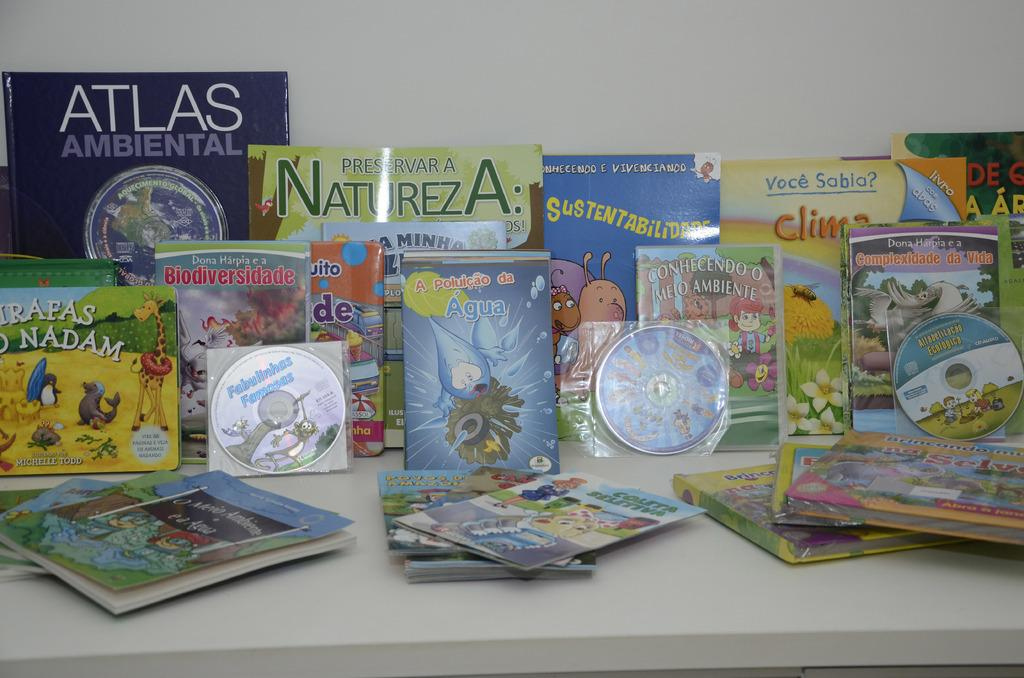Provide a one-sentence caption for the provided image. Children's books on the table and leaning against the wall in a row. 